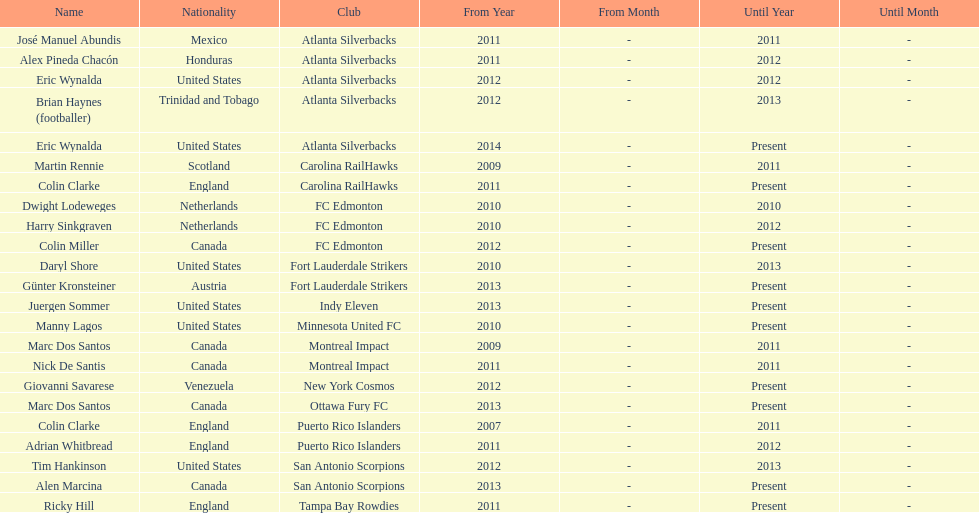How long did colin clarke coach the puerto rico islanders? 4 years. 